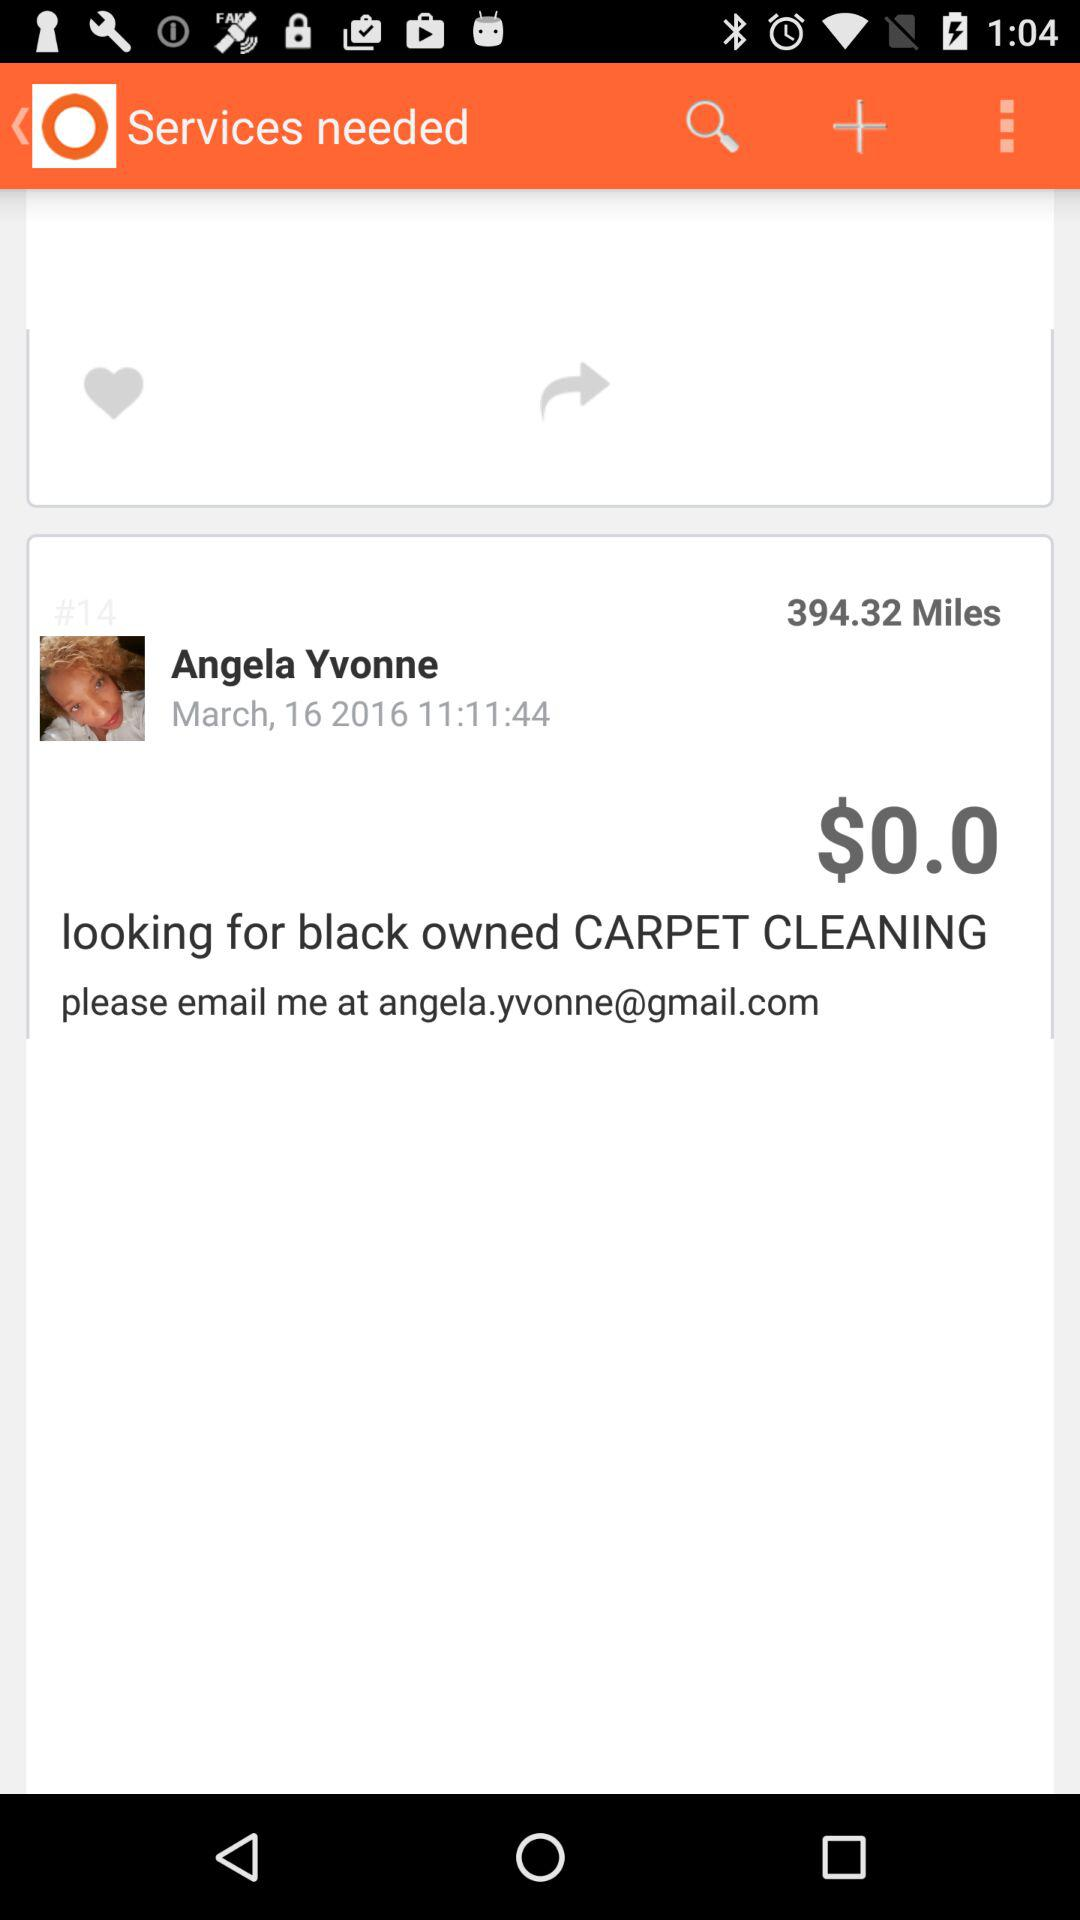What is the mentioned distance? The mentioned distance is 394.32 miles. 